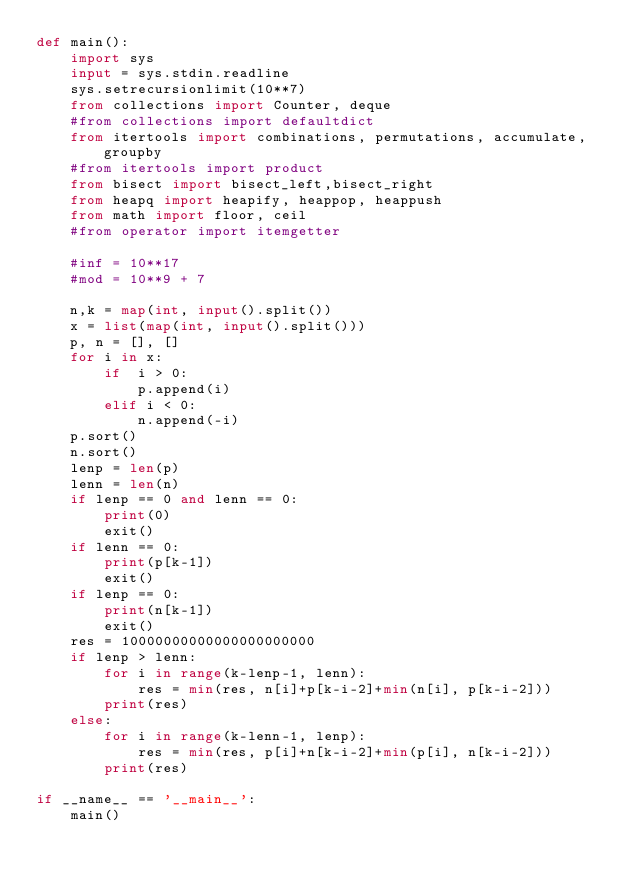<code> <loc_0><loc_0><loc_500><loc_500><_Python_>def main():
    import sys
    input = sys.stdin.readline
    sys.setrecursionlimit(10**7)
    from collections import Counter, deque
    #from collections import defaultdict
    from itertools import combinations, permutations, accumulate, groupby
    #from itertools import product
    from bisect import bisect_left,bisect_right
    from heapq import heapify, heappop, heappush
    from math import floor, ceil
    #from operator import itemgetter

    #inf = 10**17
    #mod = 10**9 + 7

    n,k = map(int, input().split())
    x = list(map(int, input().split()))
    p, n = [], []
    for i in x:
        if  i > 0:
            p.append(i)
        elif i < 0:
            n.append(-i)
    p.sort()
    n.sort()
    lenp = len(p)
    lenn = len(n)
    if lenp == 0 and lenn == 0:
        print(0)
        exit()
    if lenn == 0:
        print(p[k-1])
        exit()
    if lenp == 0:
        print(n[k-1])
        exit()
    res = 10000000000000000000000
    if lenp > lenn:
        for i in range(k-lenp-1, lenn):
            res = min(res, n[i]+p[k-i-2]+min(n[i], p[k-i-2]))
        print(res)
    else:
        for i in range(k-lenn-1, lenp):
            res = min(res, p[i]+n[k-i-2]+min(p[i], n[k-i-2]))
        print(res)

if __name__ == '__main__':
    main()</code> 